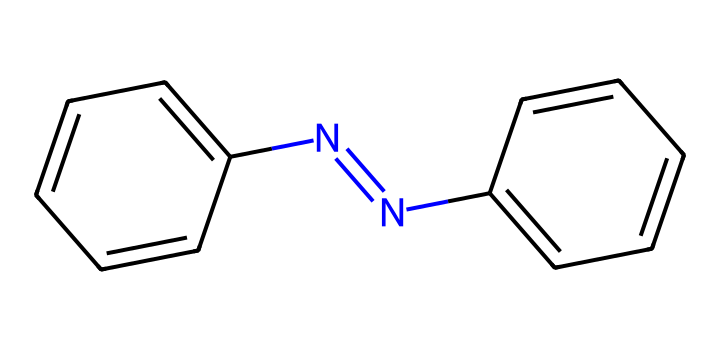What is the name of this compound? The SMILES representation indicates the structure includes a central N=N double bond flanked by two aromatic rings, which identifies it as azobenzene.
Answer: azobenzene How many nitrogen atoms are present in the molecule? By analyzing the SMILES structure, there are two nitrogen atoms involved in the N=N double bond.
Answer: two What is the total number of carbon atoms in the molecule? The composition shows there are 12 carbon atoms in total, accounted for in the two benzene rings and connecting structures.
Answer: twelve What type of chemical bond connects the two nitrogen atoms in azobenzene? The SMILES reveals a double bond (N=N) between the nitrogen atoms, which is characteristic of azobenzene.
Answer: double bond What is the main characteristic feature that classifies azobenzene as a photoreactive chemical? The presence of the nitrogen-nitrogen double bond allows for geometric isomerization upon exposure to light, which is a defining trait of photoreactive compounds.
Answer: nitrogen-nitrogen double bond How many rings are present in the azobenzene structure? The SMILES structure shows two aromatic benzene rings, indicating the presence of two rings in total.
Answer: two 